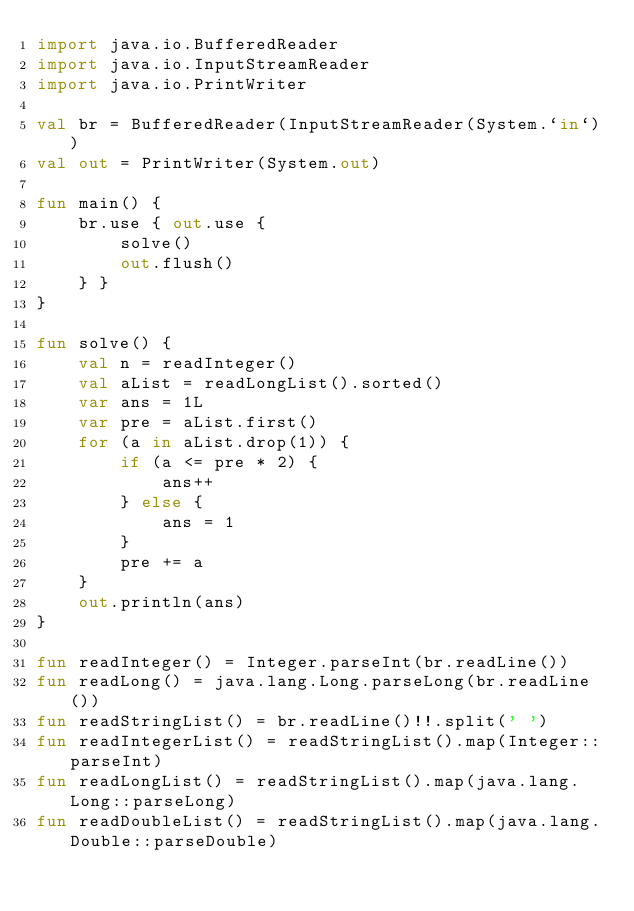<code> <loc_0><loc_0><loc_500><loc_500><_Kotlin_>import java.io.BufferedReader
import java.io.InputStreamReader
import java.io.PrintWriter

val br = BufferedReader(InputStreamReader(System.`in`))
val out = PrintWriter(System.out)

fun main() {
    br.use { out.use {
        solve()
        out.flush()
    } }
}

fun solve() {
    val n = readInteger()
    val aList = readLongList().sorted()
    var ans = 1L
    var pre = aList.first()
    for (a in aList.drop(1)) {
        if (a <= pre * 2) {
            ans++
        } else {
            ans = 1
        }
        pre += a
    }
    out.println(ans)
}

fun readInteger() = Integer.parseInt(br.readLine())
fun readLong() = java.lang.Long.parseLong(br.readLine())
fun readStringList() = br.readLine()!!.split(' ')
fun readIntegerList() = readStringList().map(Integer::parseInt)
fun readLongList() = readStringList().map(java.lang.Long::parseLong)
fun readDoubleList() = readStringList().map(java.lang.Double::parseDouble)
</code> 